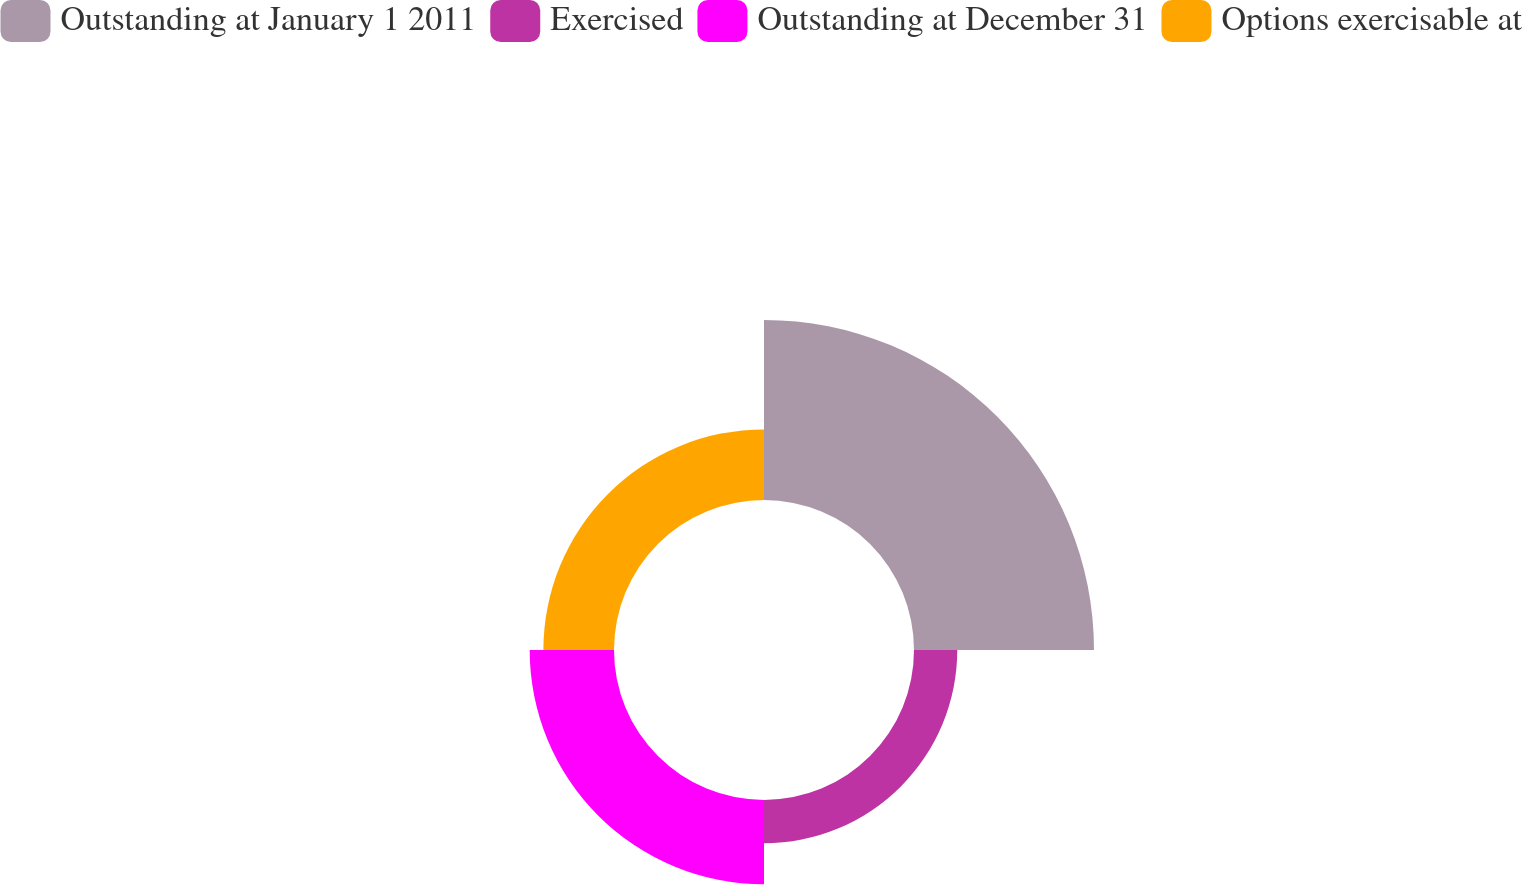<chart> <loc_0><loc_0><loc_500><loc_500><pie_chart><fcel>Outstanding at January 1 2011<fcel>Exercised<fcel>Outstanding at December 31<fcel>Options exercisable at<nl><fcel>47.59%<fcel>11.44%<fcel>22.29%<fcel>18.67%<nl></chart> 